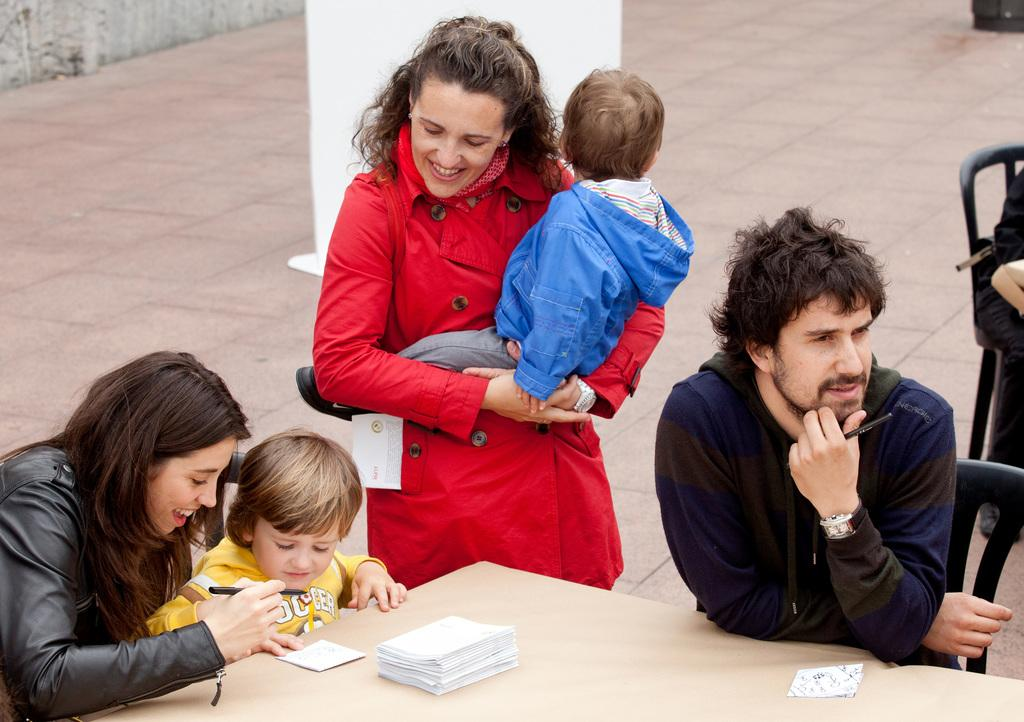What are the people in the image doing? The people in the image are sitting on chairs. What objects can be seen on the table? There are papers on the table. Can you describe the woman in the background? There is a woman wearing a red jacket in the background. What type of caption is written on the papers on the table? There is no caption visible on the papers in the image. 